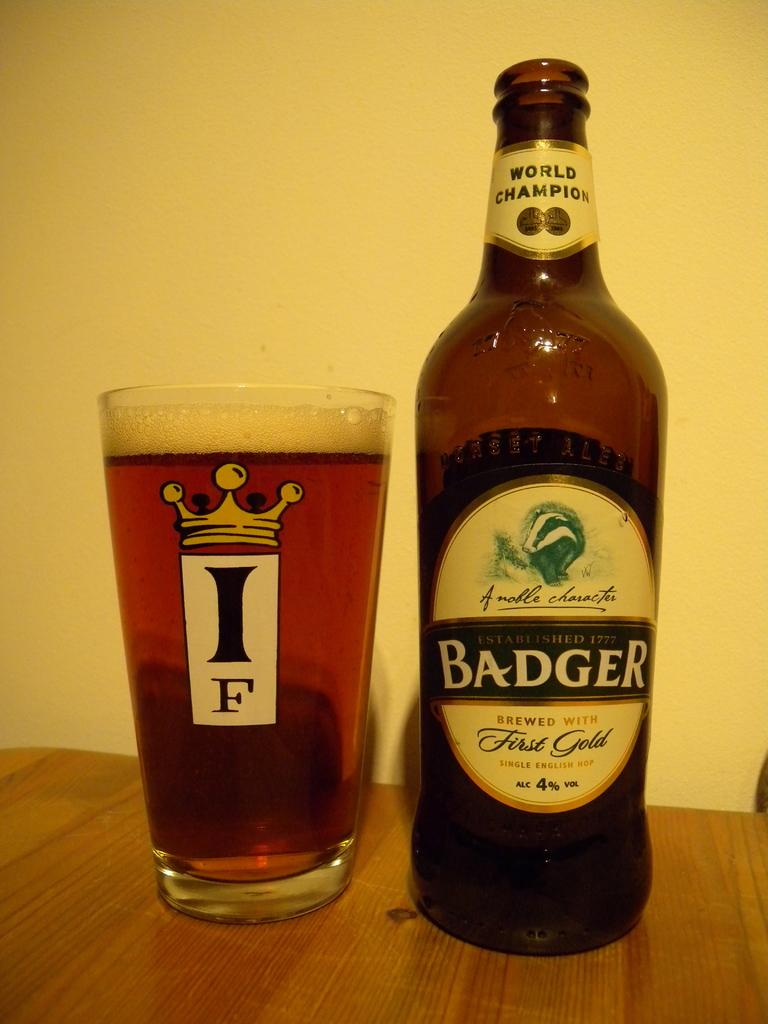Provide a one-sentence caption for the provided image. A bottle of Badger Beer has been poured into a glass on a table. 